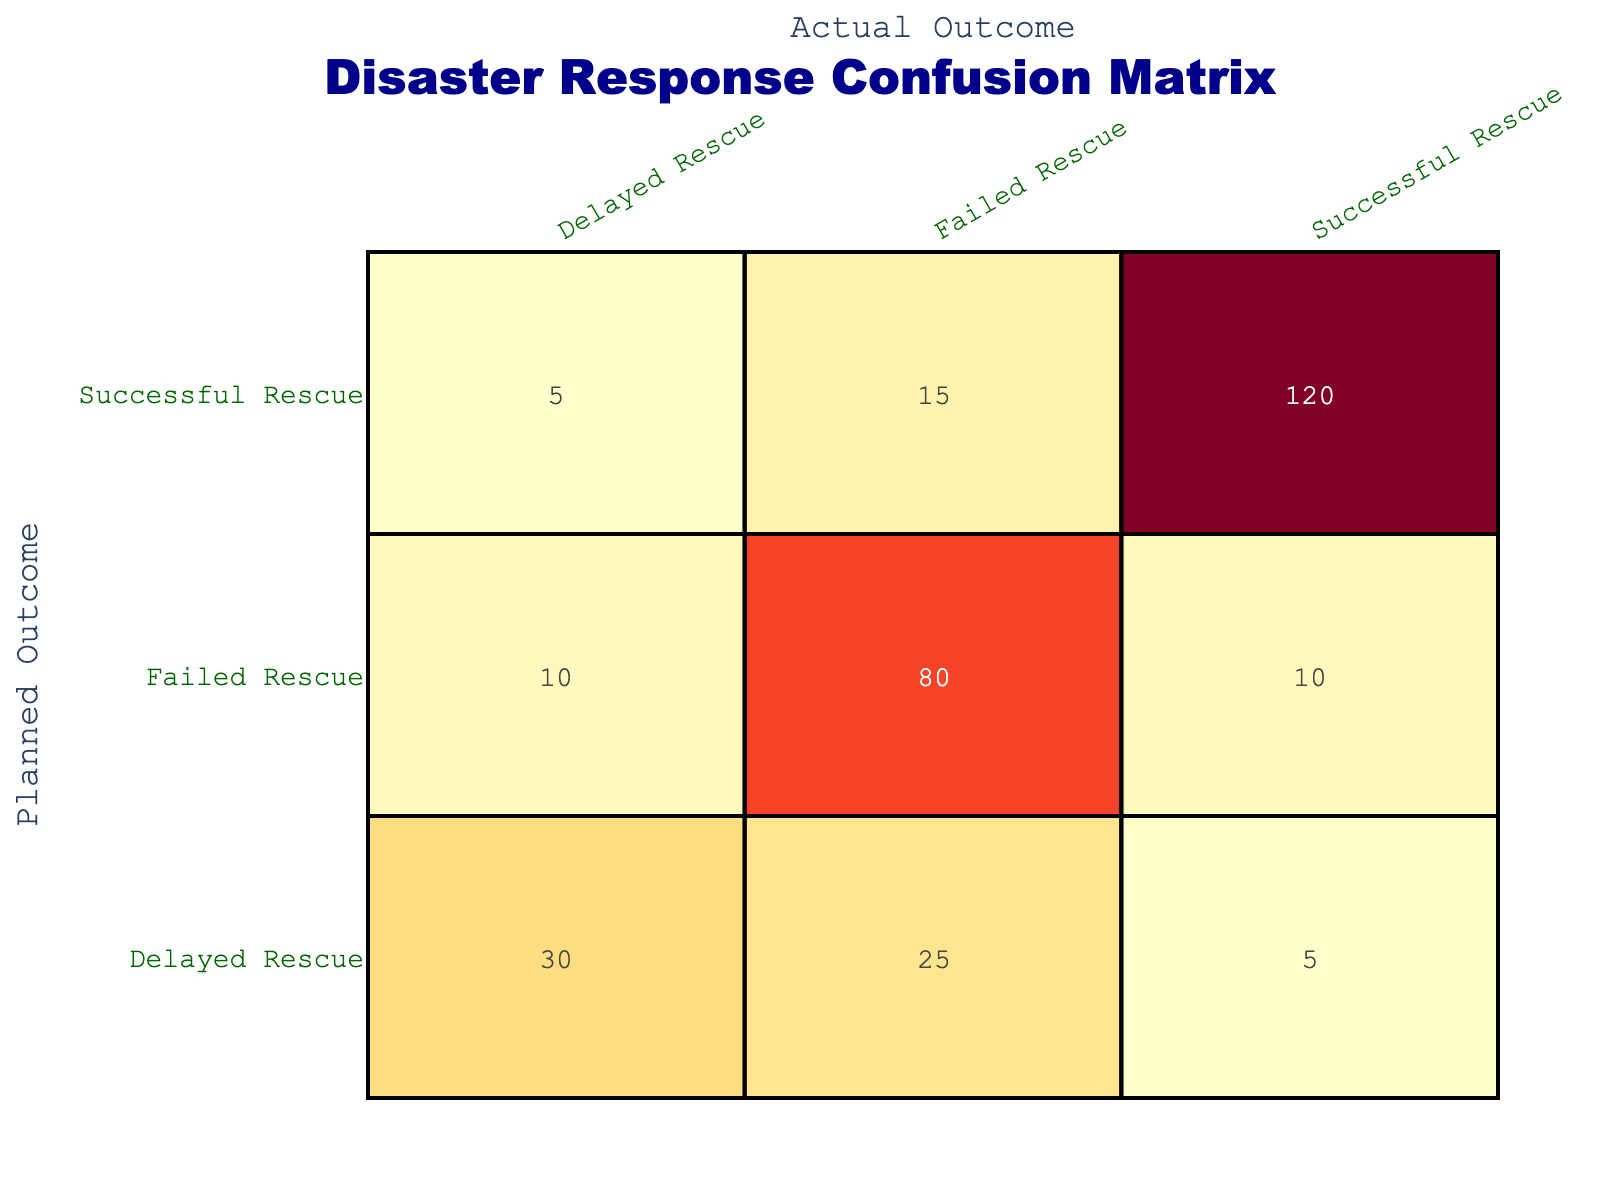What is the total count of successful rescues planned? To find the total count of successful rescues planned, we sum the counts where the Planned Outcome is "Successful Rescue". These counts are 120 (Successful Rescue, Successful Rescue), 15 (Successful Rescue, Failed Rescue), and 5 (Successful Rescue, Delayed Rescue). So, 120 + 15 + 5 = 140.
Answer: 140 How many times did rescues fail when they were planned as successful? To answer this, we need to check the count under the Planned Outcome "Successful Rescue" and Actual Outcome "Failed Rescue". This count is 15. Thus, the answer is simply the value from the table.
Answer: 15 What is the total count of delayed rescues planned? We will look for all counts where the Planned Outcome is "Delayed Rescue". These counts are 5 (Delayed Rescue, Successful Rescue), 25 (Delayed Rescue, Failed Rescue), and 30 (Delayed Rescue, Delayed Rescue). Summing them up: 5 + 25 + 30 = 60.
Answer: 60 Were there ever any instances of a successful rescue planned that ended up being delayed? Looking at the table, we find the entry for Planned Outcome "Successful Rescue" and Actual Outcome "Delayed Rescue," which has a count of 5. Therefore, the answer is yes, there were instances of this.
Answer: Yes What is the ratio of successful rescues to failed rescues planned in total? First, we find the total number of successful rescues planned by summing 140 (as calculated earlier) and the total number of failed rescues planned by summing 10 (Failed Rescue, Successful Rescue) + 80 (Failed Rescue, Failed Rescue) + 10 (Failed Rescue, Delayed Rescue) = 100. The ratio is then 140 to 100, which simplifies to 14:10 or 7:5 when reduced.
Answer: 7:5 